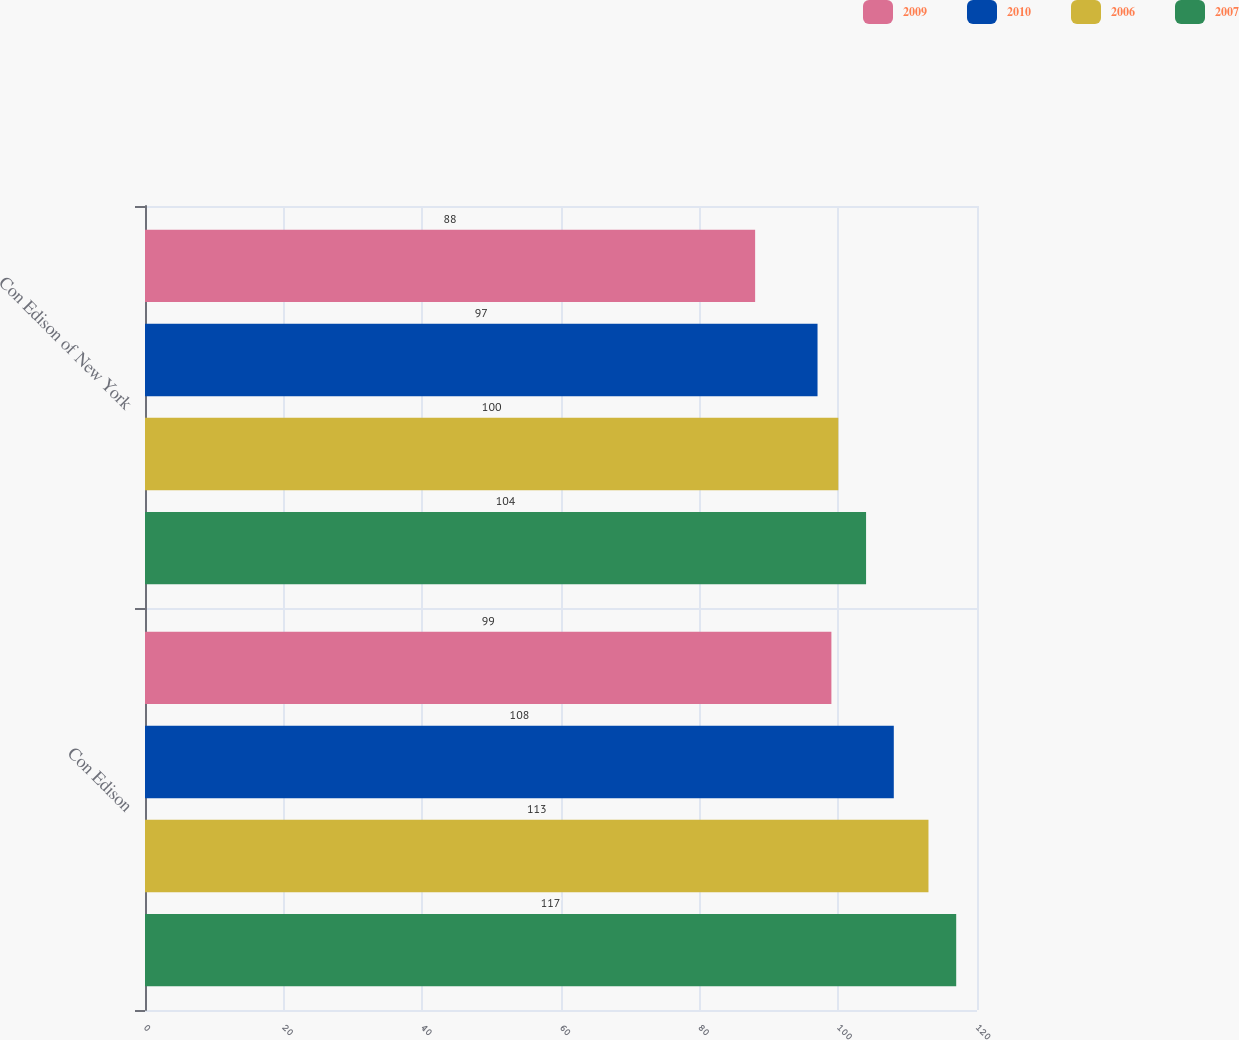Convert chart to OTSL. <chart><loc_0><loc_0><loc_500><loc_500><stacked_bar_chart><ecel><fcel>Con Edison<fcel>Con Edison of New York<nl><fcel>2009<fcel>99<fcel>88<nl><fcel>2010<fcel>108<fcel>97<nl><fcel>2006<fcel>113<fcel>100<nl><fcel>2007<fcel>117<fcel>104<nl></chart> 